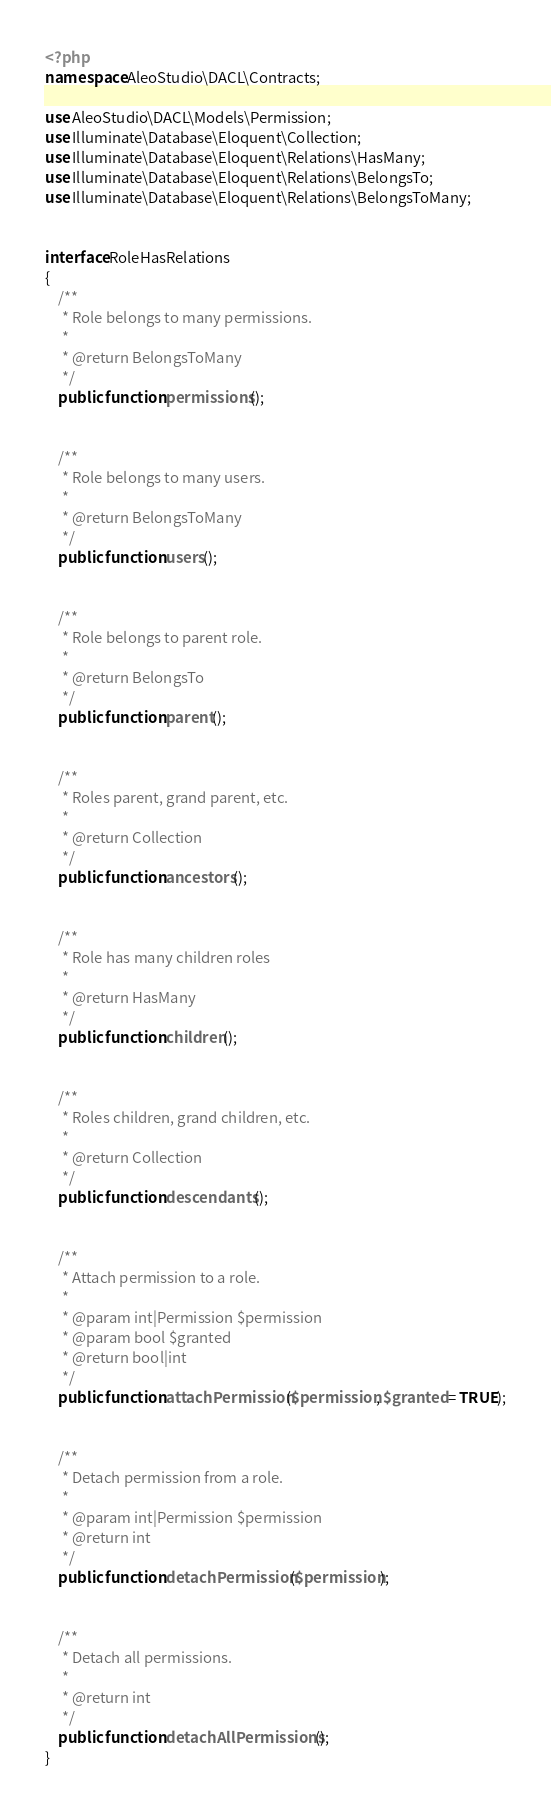<code> <loc_0><loc_0><loc_500><loc_500><_PHP_><?php
namespace AleoStudio\DACL\Contracts;

use AleoStudio\DACL\Models\Permission;
use Illuminate\Database\Eloquent\Collection;
use Illuminate\Database\Eloquent\Relations\HasMany;
use Illuminate\Database\Eloquent\Relations\BelongsTo;
use Illuminate\Database\Eloquent\Relations\BelongsToMany;


interface RoleHasRelations
{
    /**
     * Role belongs to many permissions.
     *
     * @return BelongsToMany
     */
    public function permissions();


    /**
     * Role belongs to many users.
     *
     * @return BelongsToMany
     */
    public function users();


    /**
     * Role belongs to parent role.
     *
     * @return BelongsTo
     */
    public function parent();


    /**
     * Roles parent, grand parent, etc.
     *
     * @return Collection
     */
    public function ancestors();


    /**
     * Role has many children roles
     *
     * @return HasMany
     */
    public function children();


    /**
     * Roles children, grand children, etc.
     *
     * @return Collection
     */
    public function descendants();


    /**
     * Attach permission to a role.
     *
     * @param int|Permission $permission
     * @param bool $granted
     * @return bool|int
     */
    public function attachPermission($permission, $granted = TRUE);


    /**
     * Detach permission from a role.
     *
     * @param int|Permission $permission
     * @return int
     */
    public function detachPermission($permission);


    /**
     * Detach all permissions.
     *
     * @return int
     */
    public function detachAllPermissions();
}
</code> 